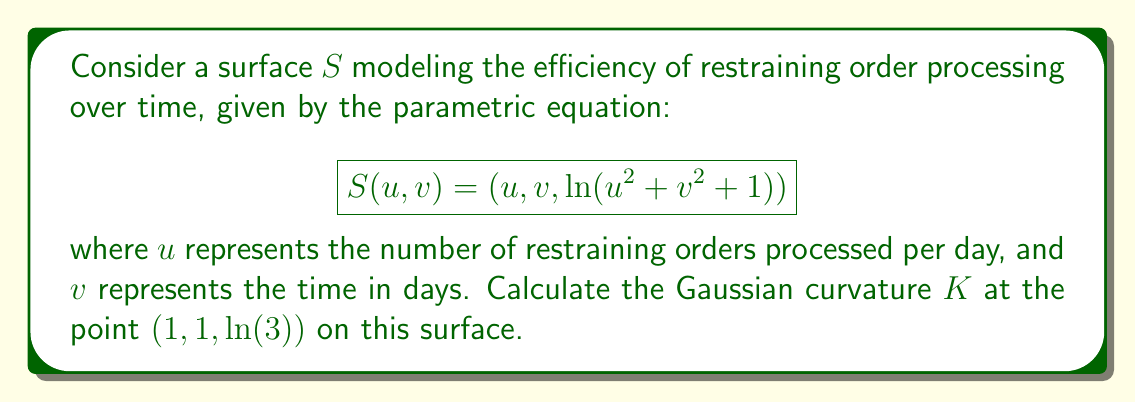Can you answer this question? To find the Gaussian curvature, we need to follow these steps:

1) First, we need to calculate the partial derivatives:

   $S_u = (1, 0, \frac{2u}{u^2 + v^2 + 1})$
   $S_v = (0, 1, \frac{2v}{u^2 + v^2 + 1})$

2) Next, we calculate the second partial derivatives:

   $S_{uu} = (0, 0, \frac{2(u^2 + v^2 + 1) - 4u^2}{(u^2 + v^2 + 1)^2})$
   $S_{uv} = (0, 0, \frac{-4uv}{(u^2 + v^2 + 1)^2})$
   $S_{vv} = (0, 0, \frac{2(u^2 + v^2 + 1) - 4v^2}{(u^2 + v^2 + 1)^2})$

3) Now we can calculate the coefficients of the first fundamental form:

   $E = S_u \cdot S_u = 1 + (\frac{2u}{u^2 + v^2 + 1})^2$
   $F = S_u \cdot S_v = \frac{4uv}{(u^2 + v^2 + 1)^2}$
   $G = S_v \cdot S_v = 1 + (\frac{2v}{u^2 + v^2 + 1})^2$

4) And the coefficients of the second fundamental form:

   $e = S_{uu} \cdot N = \frac{2(u^2 + v^2 + 1) - 4u^2}{(u^2 + v^2 + 1)^2} \cdot \frac{1}{\sqrt{1 + \frac{4u^2}{(u^2 + v^2 + 1)^2} + \frac{4v^2}{(u^2 + v^2 + 1)^2}}}$
   
   $f = S_{uv} \cdot N = \frac{-4uv}{(u^2 + v^2 + 1)^2} \cdot \frac{1}{\sqrt{1 + \frac{4u^2}{(u^2 + v^2 + 1)^2} + \frac{4v^2}{(u^2 + v^2 + 1)^2}}}$
   
   $g = S_{vv} \cdot N = \frac{2(u^2 + v^2 + 1) - 4v^2}{(u^2 + v^2 + 1)^2} \cdot \frac{1}{\sqrt{1 + \frac{4u^2}{(u^2 + v^2 + 1)^2} + \frac{4v^2}{(u^2 + v^2 + 1)^2}}}$

5) The Gaussian curvature is given by:

   $K = \frac{eg - f^2}{EG - F^2}$

6) At the point (1, 1, ln(3)), we have u = 1 and v = 1. Substituting these values:

   $K = \frac{(\frac{2}{9} \cdot \frac{1}{\sqrt{5/3}})(\frac{2}{9} \cdot \frac{1}{\sqrt{5/3}}) - (\frac{-4}{9} \cdot \frac{1}{\sqrt{5/3}})^2}{(1 + \frac{4}{9})(1 + \frac{4}{9}) - (\frac{4}{9})^2}$

7) Simplifying:

   $K = \frac{4/81 - 16/81}{25/9 - 16/81} = \frac{-12/81}{225/81} = -\frac{4}{75}$
Answer: $-\frac{4}{75}$ 